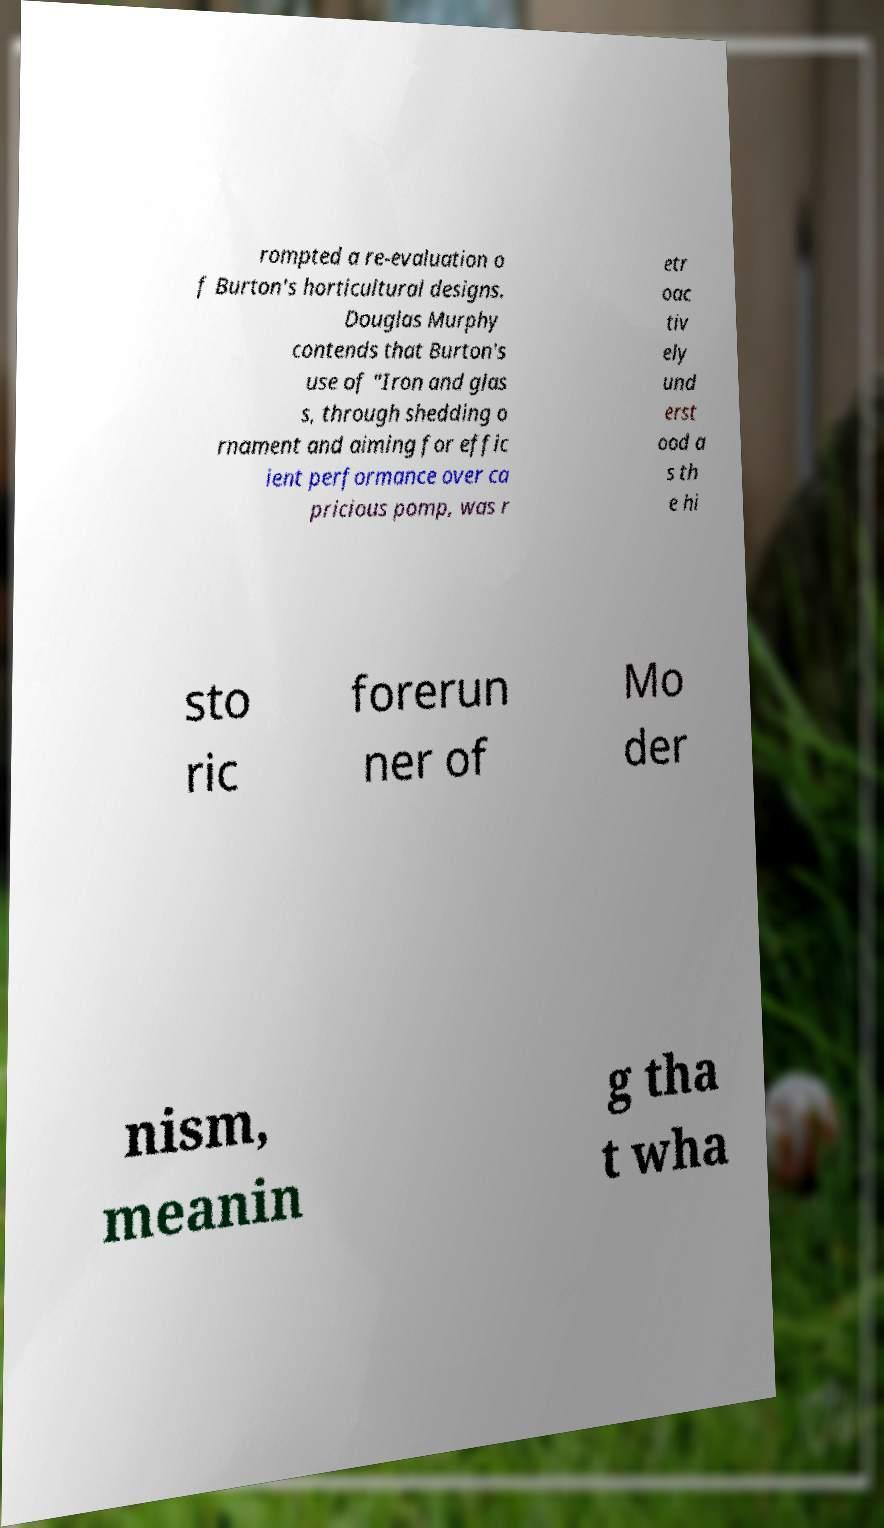Please read and relay the text visible in this image. What does it say? rompted a re-evaluation o f Burton's horticultural designs. Douglas Murphy contends that Burton's use of "Iron and glas s, through shedding o rnament and aiming for effic ient performance over ca pricious pomp, was r etr oac tiv ely und erst ood a s th e hi sto ric forerun ner of Mo der nism, meanin g tha t wha 